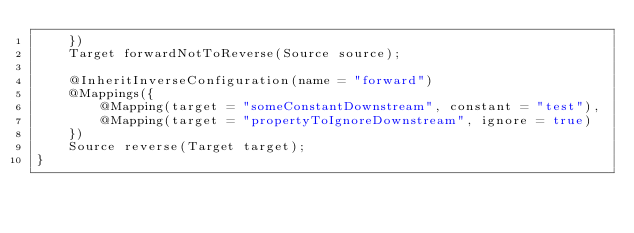<code> <loc_0><loc_0><loc_500><loc_500><_Java_>    })
    Target forwardNotToReverse(Source source);

    @InheritInverseConfiguration(name = "forward")
    @Mappings({
        @Mapping(target = "someConstantDownstream", constant = "test"),
        @Mapping(target = "propertyToIgnoreDownstream", ignore = true)
    })
    Source reverse(Target target);
}
</code> 